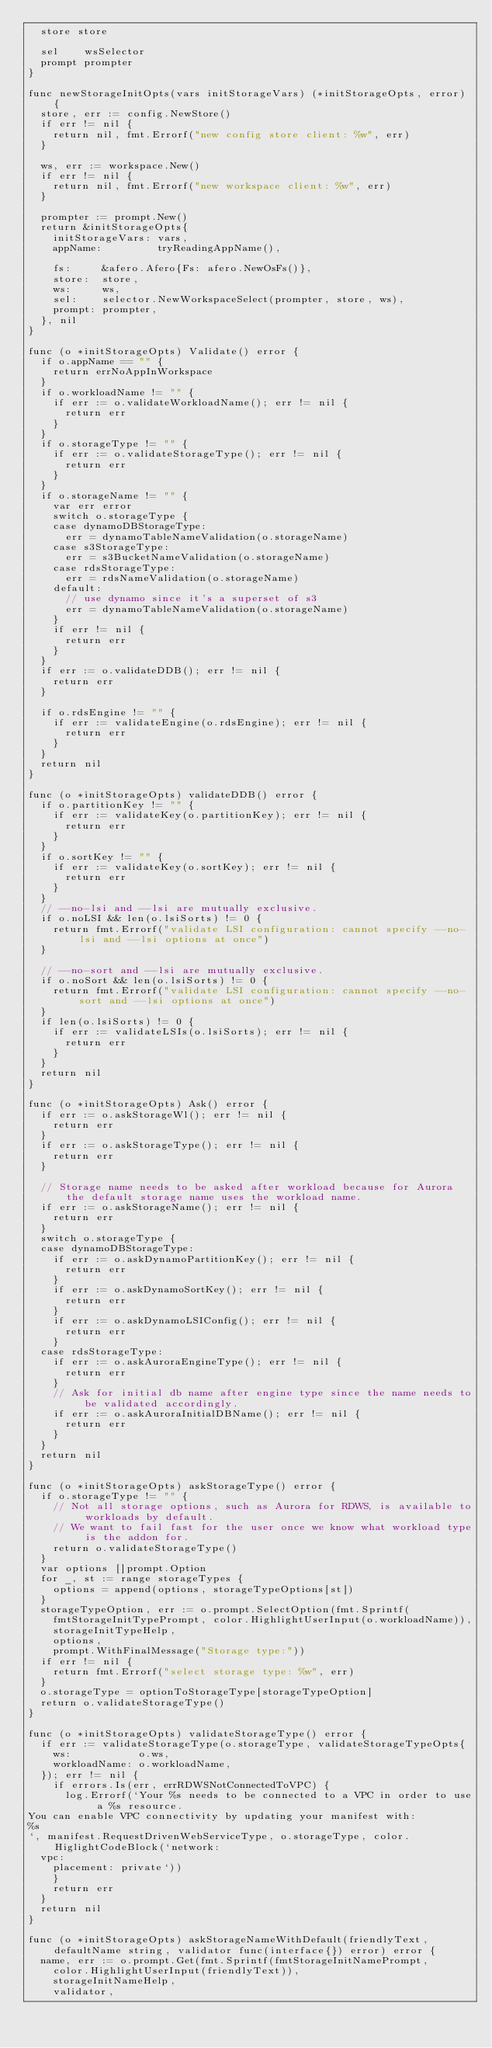Convert code to text. <code><loc_0><loc_0><loc_500><loc_500><_Go_>	store store

	sel    wsSelector
	prompt prompter
}

func newStorageInitOpts(vars initStorageVars) (*initStorageOpts, error) {
	store, err := config.NewStore()
	if err != nil {
		return nil, fmt.Errorf("new config store client: %w", err)
	}

	ws, err := workspace.New()
	if err != nil {
		return nil, fmt.Errorf("new workspace client: %w", err)
	}

	prompter := prompt.New()
	return &initStorageOpts{
		initStorageVars: vars,
		appName:         tryReadingAppName(),

		fs:     &afero.Afero{Fs: afero.NewOsFs()},
		store:  store,
		ws:     ws,
		sel:    selector.NewWorkspaceSelect(prompter, store, ws),
		prompt: prompter,
	}, nil
}

func (o *initStorageOpts) Validate() error {
	if o.appName == "" {
		return errNoAppInWorkspace
	}
	if o.workloadName != "" {
		if err := o.validateWorkloadName(); err != nil {
			return err
		}
	}
	if o.storageType != "" {
		if err := o.validateStorageType(); err != nil {
			return err
		}
	}
	if o.storageName != "" {
		var err error
		switch o.storageType {
		case dynamoDBStorageType:
			err = dynamoTableNameValidation(o.storageName)
		case s3StorageType:
			err = s3BucketNameValidation(o.storageName)
		case rdsStorageType:
			err = rdsNameValidation(o.storageName)
		default:
			// use dynamo since it's a superset of s3
			err = dynamoTableNameValidation(o.storageName)
		}
		if err != nil {
			return err
		}
	}
	if err := o.validateDDB(); err != nil {
		return err
	}

	if o.rdsEngine != "" {
		if err := validateEngine(o.rdsEngine); err != nil {
			return err
		}
	}
	return nil
}

func (o *initStorageOpts) validateDDB() error {
	if o.partitionKey != "" {
		if err := validateKey(o.partitionKey); err != nil {
			return err
		}
	}
	if o.sortKey != "" {
		if err := validateKey(o.sortKey); err != nil {
			return err
		}
	}
	// --no-lsi and --lsi are mutually exclusive.
	if o.noLSI && len(o.lsiSorts) != 0 {
		return fmt.Errorf("validate LSI configuration: cannot specify --no-lsi and --lsi options at once")
	}

	// --no-sort and --lsi are mutually exclusive.
	if o.noSort && len(o.lsiSorts) != 0 {
		return fmt.Errorf("validate LSI configuration: cannot specify --no-sort and --lsi options at once")
	}
	if len(o.lsiSorts) != 0 {
		if err := validateLSIs(o.lsiSorts); err != nil {
			return err
		}
	}
	return nil
}

func (o *initStorageOpts) Ask() error {
	if err := o.askStorageWl(); err != nil {
		return err
	}
	if err := o.askStorageType(); err != nil {
		return err
	}

	// Storage name needs to be asked after workload because for Aurora the default storage name uses the workload name.
	if err := o.askStorageName(); err != nil {
		return err
	}
	switch o.storageType {
	case dynamoDBStorageType:
		if err := o.askDynamoPartitionKey(); err != nil {
			return err
		}
		if err := o.askDynamoSortKey(); err != nil {
			return err
		}
		if err := o.askDynamoLSIConfig(); err != nil {
			return err
		}
	case rdsStorageType:
		if err := o.askAuroraEngineType(); err != nil {
			return err
		}
		// Ask for initial db name after engine type since the name needs to be validated accordingly.
		if err := o.askAuroraInitialDBName(); err != nil {
			return err
		}
	}
	return nil
}

func (o *initStorageOpts) askStorageType() error {
	if o.storageType != "" {
		// Not all storage options, such as Aurora for RDWS, is available to workloads by default.
		// We want to fail fast for the user once we know what workload type is the addon for.
		return o.validateStorageType()
	}
	var options []prompt.Option
	for _, st := range storageTypes {
		options = append(options, storageTypeOptions[st])
	}
	storageTypeOption, err := o.prompt.SelectOption(fmt.Sprintf(
		fmtStorageInitTypePrompt, color.HighlightUserInput(o.workloadName)),
		storageInitTypeHelp,
		options,
		prompt.WithFinalMessage("Storage type:"))
	if err != nil {
		return fmt.Errorf("select storage type: %w", err)
	}
	o.storageType = optionToStorageType[storageTypeOption]
	return o.validateStorageType()
}

func (o *initStorageOpts) validateStorageType() error {
	if err := validateStorageType(o.storageType, validateStorageTypeOpts{
		ws:           o.ws,
		workloadName: o.workloadName,
	}); err != nil {
		if errors.Is(err, errRDWSNotConnectedToVPC) {
			log.Errorf(`Your %s needs to be connected to a VPC in order to use a %s resource.
You can enable VPC connectivity by updating your manifest with:
%s
`, manifest.RequestDrivenWebServiceType, o.storageType, color.HiglightCodeBlock(`network:
  vpc:
    placement: private`))
		}
		return err
	}
	return nil
}

func (o *initStorageOpts) askStorageNameWithDefault(friendlyText, defaultName string, validator func(interface{}) error) error {
	name, err := o.prompt.Get(fmt.Sprintf(fmtStorageInitNamePrompt,
		color.HighlightUserInput(friendlyText)),
		storageInitNameHelp,
		validator,</code> 